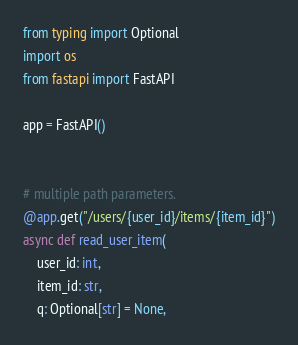<code> <loc_0><loc_0><loc_500><loc_500><_Python_>from typing import Optional
import os
from fastapi import FastAPI

app = FastAPI()


# multiple path parameters.
@app.get("/users/{user_id}/items/{item_id}")
async def read_user_item(
    user_id: int,
    item_id: str,
    q: Optional[str] = None,</code> 